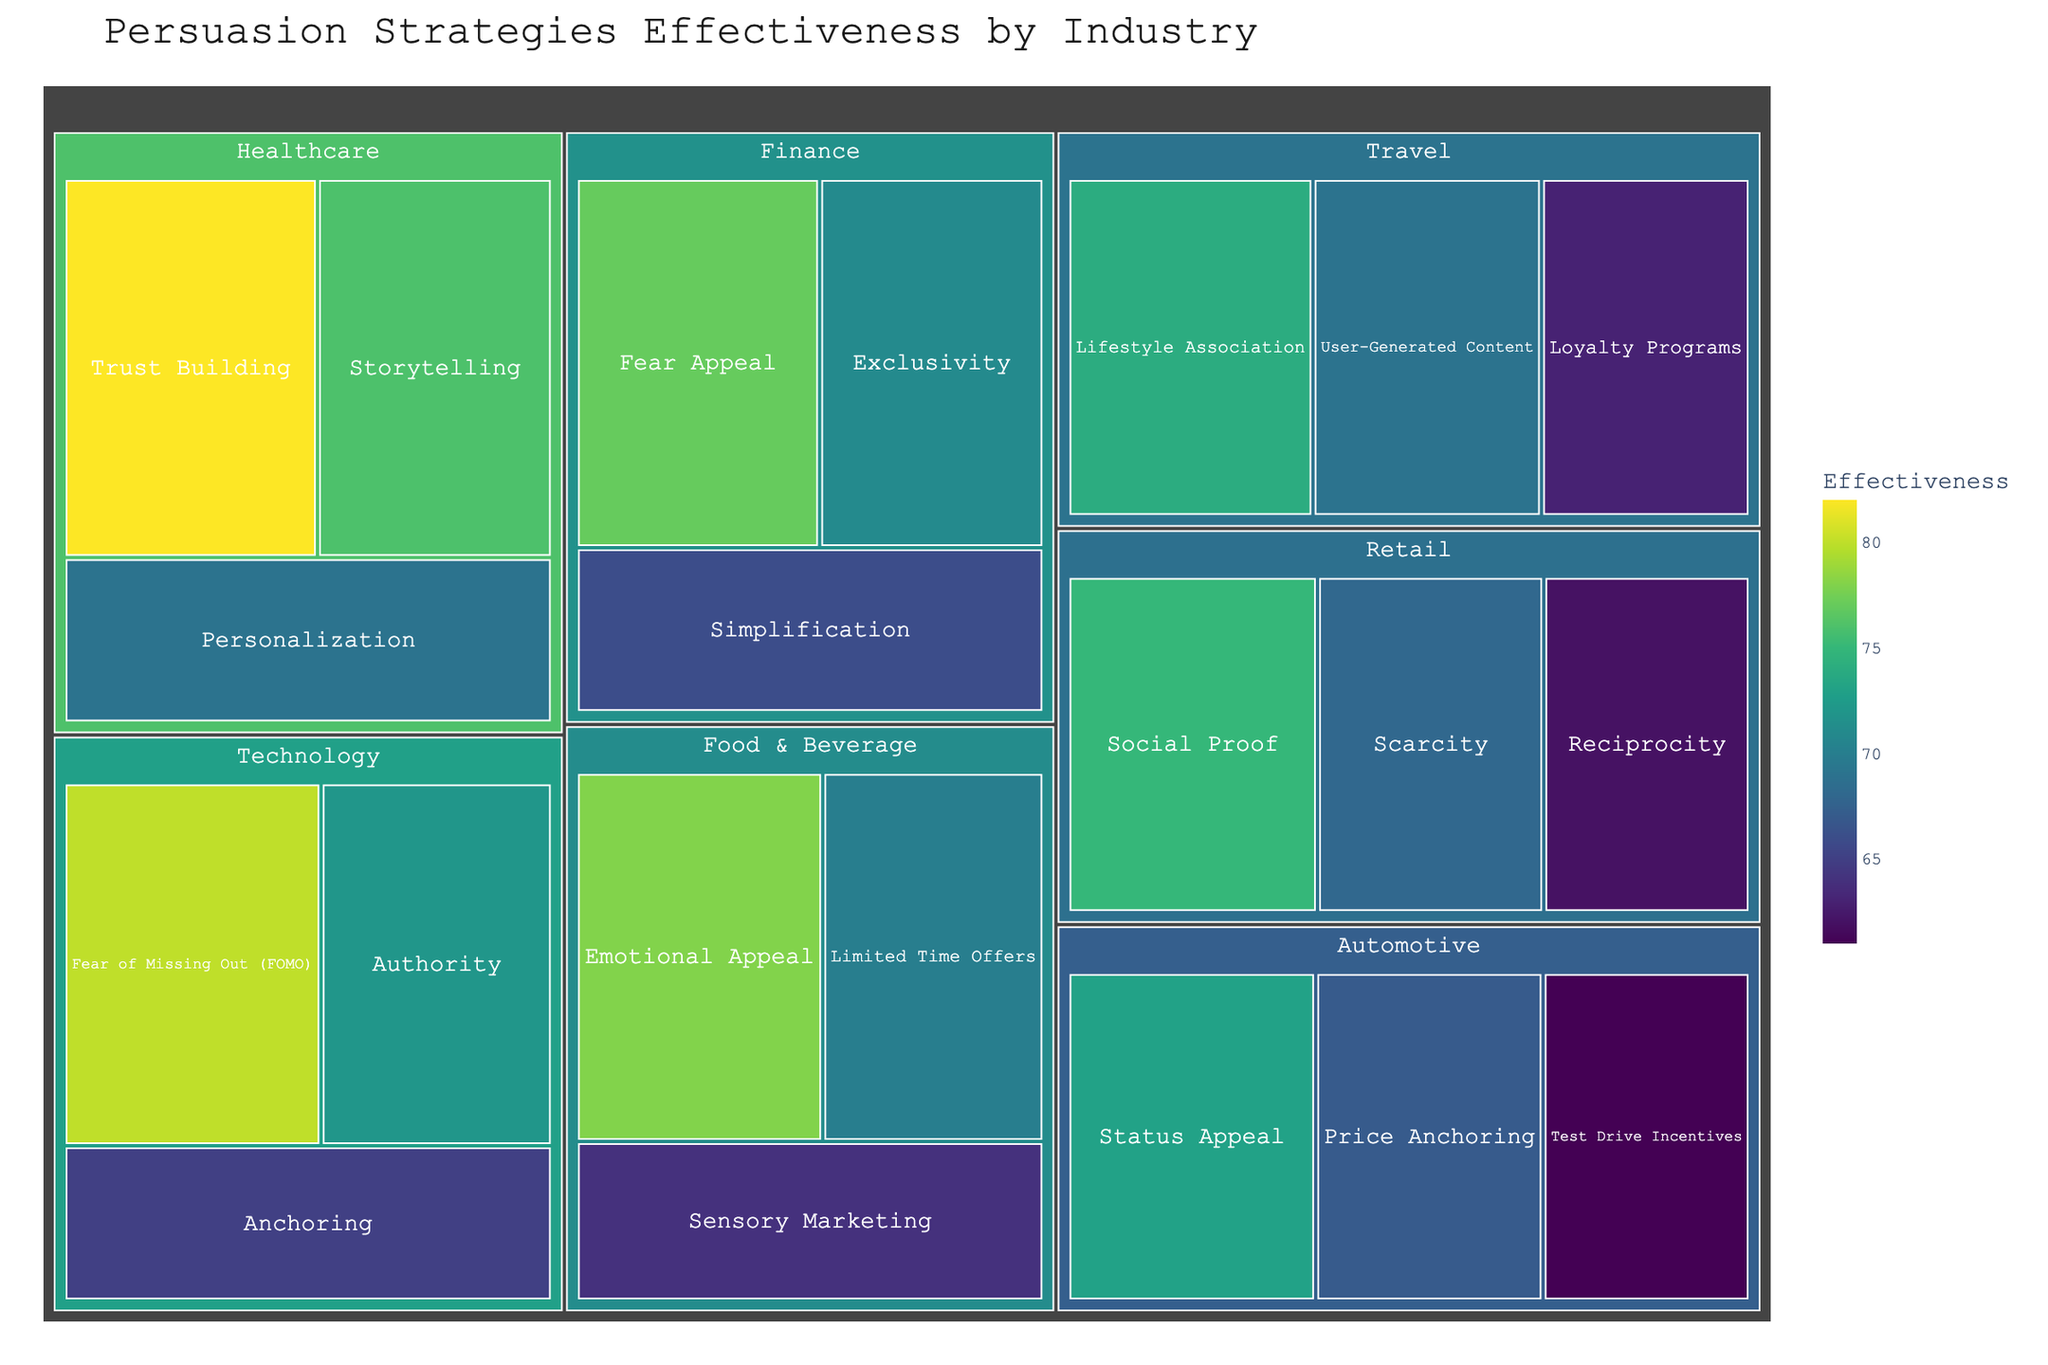Which industry has the most effective persuasion strategy? The most effective persuasion strategy is in the Healthcare industry with Trust Building having an effectiveness of 82%.
Answer: Healthcare What is the least effective strategy in the Automotive industry? The least effective strategy in the Automotive industry is Test Drive Incentives with an effectiveness of 61%.
Answer: Test Drive Incentives Compare the effectiveness of Social Proof in Retail with Fear of Missing Out (FOMO) in Technology. Which is more effective? Social Proof in Retail has an effectiveness of 75%, while FOMO in Technology has an effectiveness of 80%. FOMO in Technology is more effective.
Answer: Fear of Missing Out (FOMO) Which strategy in the Food & Beverage industry has the highest effectiveness? In the Food & Beverage industry, Emotional Appeal strategy has the highest effectiveness of 78%.
Answer: Emotional Appeal Calculate the average effectiveness of all strategies in the Finance industry. The effectiveness in the Finance industry are Fear Appeal (77%), Exclusivity (71%), and Simplification (66%). The average effectiveness is (77 + 71 + 66) / 3 = 71.33.
Answer: 71.33 Which industry uses the strategy of Lifestyle Association, and what is its effectiveness? The strategy of Lifestyle Association is used in the Travel industry with an effectiveness of 74%.
Answer: Travel, 74% Compare the effectiveness of Storytelling in Healthcare with Limited Time Offers in Food & Beverage. Which strategy has higher effectiveness? Storytelling in Healthcare has an effectiveness of 76%, while Limited Time Offers in Food & Beverage has an effectiveness of 70%. Storytelling in Healthcare is more effective.
Answer: Storytelling Is Sensory Marketing more effective than Test Drive Incentives? Sensory Marketing has an effectiveness of 64%, while Test Drive Incentives has an effectiveness of 61%. Sensory Marketing is more effective.
Answer: Yes What's the difference in effectiveness between Trust Building in Healthcare and Status Appeal in Automotive? The effectiveness of Trust Building in Healthcare is 82%, while Status Appeal in Automotive is 73%. The difference is 82 - 73 = 9.
Answer: 9 